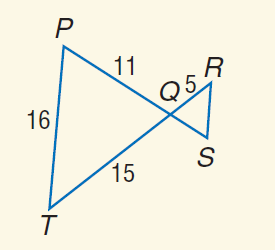Answer the mathemtical geometry problem and directly provide the correct option letter.
Question: Find the perimeter of \triangle Q R S if \triangle Q R S \sim \triangle Q T P.
Choices: A: 9 B: 14 C: 21 D: 42 B 